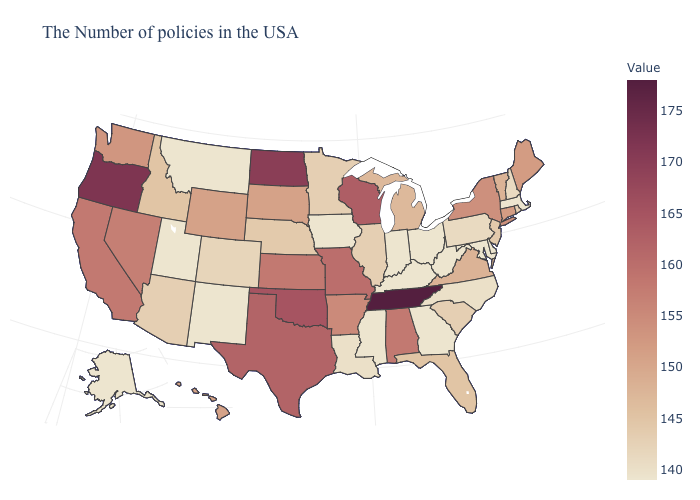Does Alabama have the highest value in the South?
Short answer required. No. Is the legend a continuous bar?
Write a very short answer. Yes. Does the map have missing data?
Short answer required. No. 